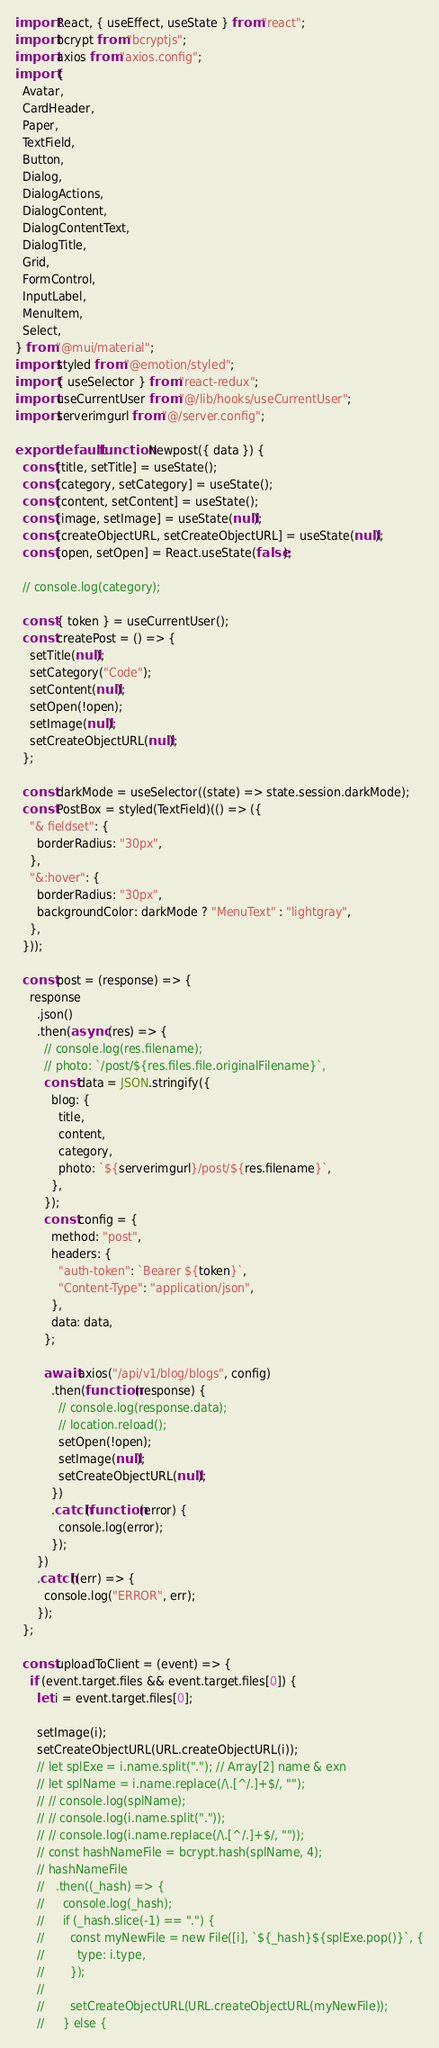Convert code to text. <code><loc_0><loc_0><loc_500><loc_500><_JavaScript_>import React, { useEffect, useState } from "react";
import bcrypt from "bcryptjs";
import axios from "axios.config";
import {
  Avatar,
  CardHeader,
  Paper,
  TextField,
  Button,
  Dialog,
  DialogActions,
  DialogContent,
  DialogContentText,
  DialogTitle,
  Grid,
  FormControl,
  InputLabel,
  MenuItem,
  Select,
} from "@mui/material";
import styled from "@emotion/styled";
import { useSelector } from "react-redux";
import useCurrentUser from "@/lib/hooks/useCurrentUser";
import serverimgurl from "@/server.config";

export default function Newpost({ data }) {
  const [title, setTitle] = useState();
  const [category, setCategory] = useState();
  const [content, setContent] = useState();
  const [image, setImage] = useState(null);
  const [createObjectURL, setCreateObjectURL] = useState(null);
  const [open, setOpen] = React.useState(false);

  // console.log(category);

  const { token } = useCurrentUser();
  const createPost = () => {
    setTitle(null);
    setCategory("Code");
    setContent(null);
    setOpen(!open);
    setImage(null);
    setCreateObjectURL(null);
  };

  const darkMode = useSelector((state) => state.session.darkMode);
  const PostBox = styled(TextField)(() => ({
    "& fieldset": {
      borderRadius: "30px",
    },
    "&:hover": {
      borderRadius: "30px",
      backgroundColor: darkMode ? "MenuText" : "lightgray",
    },
  }));

  const post = (response) => {
    response
      .json()
      .then(async (res) => {
        // console.log(res.filename);
        // photo: `/post/${res.files.file.originalFilename}`,
        const data = JSON.stringify({
          blog: {
            title,
            content,
            category,
            photo: `${serverimgurl}/post/${res.filename}`,
          },
        });
        const config = {
          method: "post",
          headers: {
            "auth-token": `Bearer ${token}`,
            "Content-Type": "application/json",
          },
          data: data,
        };

        await axios("/api/v1/blog/blogs", config)
          .then(function (response) {
            // console.log(response.data);
            // location.reload();
            setOpen(!open);
            setImage(null);
            setCreateObjectURL(null);
          })
          .catch(function (error) {
            console.log(error);
          });
      })
      .catch((err) => {
        console.log("ERROR", err);
      });
  };

  const uploadToClient = (event) => {
    if (event.target.files && event.target.files[0]) {
      let i = event.target.files[0];

      setImage(i);
      setCreateObjectURL(URL.createObjectURL(i));
      // let splExe = i.name.split("."); // Array[2] name & exn
      // let splName = i.name.replace(/\.[^/.]+$/, "");
      // // console.log(splName);
      // // console.log(i.name.split("."));
      // // console.log(i.name.replace(/\.[^/.]+$/, ""));
      // const hashNameFile = bcrypt.hash(splName, 4);
      // hashNameFile
      //   .then((_hash) => {
      //     console.log(_hash);
      //     if (_hash.slice(-1) == ".") {
      //       const myNewFile = new File([i], `${_hash}${splExe.pop()}`, {
      //         type: i.type,
      //       });
      //
      //       setCreateObjectURL(URL.createObjectURL(myNewFile));
      //     } else {</code> 